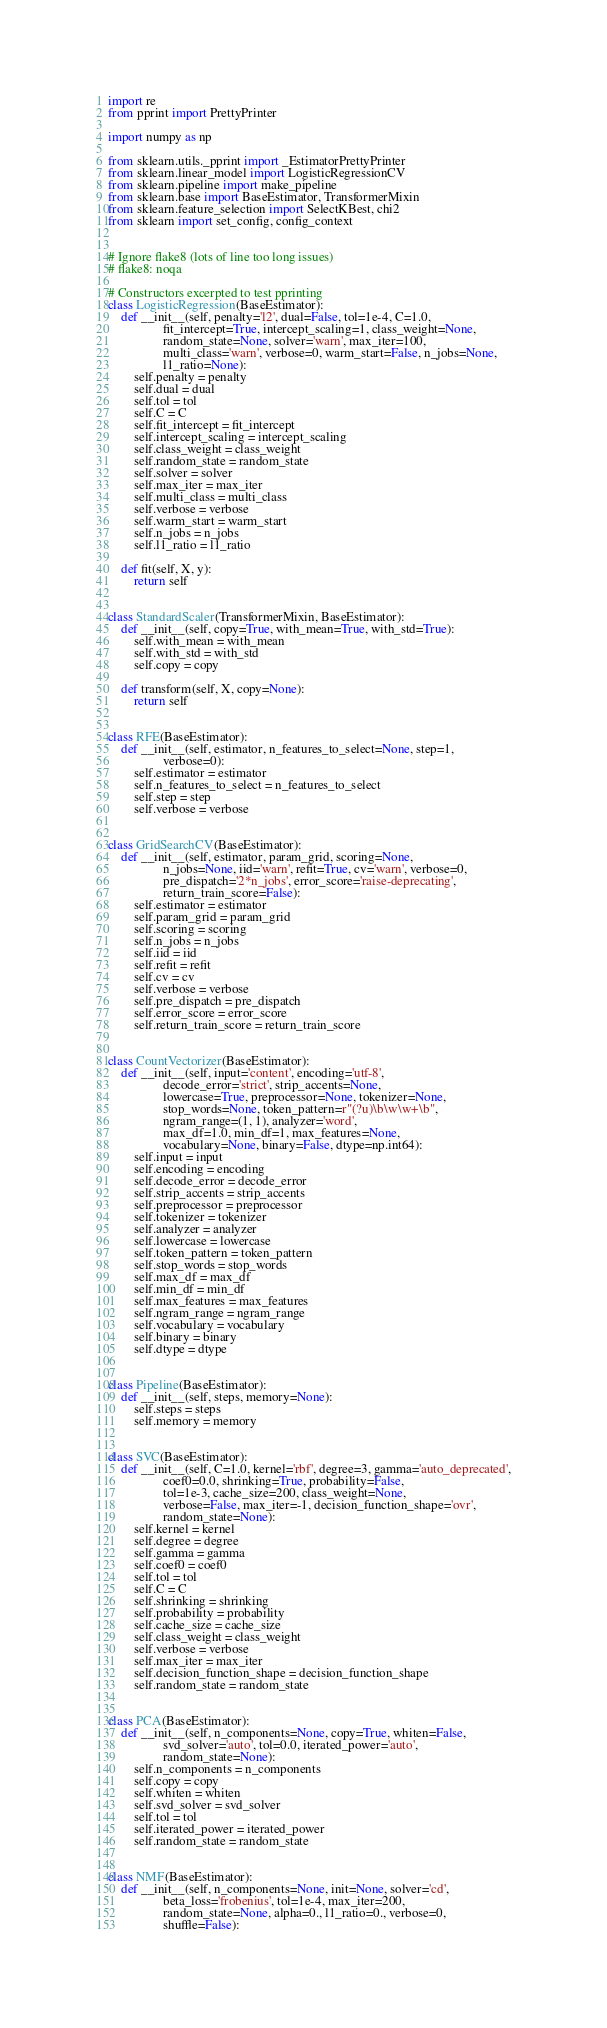Convert code to text. <code><loc_0><loc_0><loc_500><loc_500><_Python_>import re
from pprint import PrettyPrinter

import numpy as np

from sklearn.utils._pprint import _EstimatorPrettyPrinter
from sklearn.linear_model import LogisticRegressionCV
from sklearn.pipeline import make_pipeline
from sklearn.base import BaseEstimator, TransformerMixin
from sklearn.feature_selection import SelectKBest, chi2
from sklearn import set_config, config_context


# Ignore flake8 (lots of line too long issues)
# flake8: noqa

# Constructors excerpted to test pprinting
class LogisticRegression(BaseEstimator):
    def __init__(self, penalty='l2', dual=False, tol=1e-4, C=1.0,
                 fit_intercept=True, intercept_scaling=1, class_weight=None,
                 random_state=None, solver='warn', max_iter=100,
                 multi_class='warn', verbose=0, warm_start=False, n_jobs=None,
                 l1_ratio=None):
        self.penalty = penalty
        self.dual = dual
        self.tol = tol
        self.C = C
        self.fit_intercept = fit_intercept
        self.intercept_scaling = intercept_scaling
        self.class_weight = class_weight
        self.random_state = random_state
        self.solver = solver
        self.max_iter = max_iter
        self.multi_class = multi_class
        self.verbose = verbose
        self.warm_start = warm_start
        self.n_jobs = n_jobs
        self.l1_ratio = l1_ratio

    def fit(self, X, y):
        return self


class StandardScaler(TransformerMixin, BaseEstimator):
    def __init__(self, copy=True, with_mean=True, with_std=True):
        self.with_mean = with_mean
        self.with_std = with_std
        self.copy = copy

    def transform(self, X, copy=None):
        return self


class RFE(BaseEstimator):
    def __init__(self, estimator, n_features_to_select=None, step=1,
                 verbose=0):
        self.estimator = estimator
        self.n_features_to_select = n_features_to_select
        self.step = step
        self.verbose = verbose


class GridSearchCV(BaseEstimator):
    def __init__(self, estimator, param_grid, scoring=None,
                 n_jobs=None, iid='warn', refit=True, cv='warn', verbose=0,
                 pre_dispatch='2*n_jobs', error_score='raise-deprecating',
                 return_train_score=False):
        self.estimator = estimator
        self.param_grid = param_grid
        self.scoring = scoring
        self.n_jobs = n_jobs
        self.iid = iid
        self.refit = refit
        self.cv = cv
        self.verbose = verbose
        self.pre_dispatch = pre_dispatch
        self.error_score = error_score
        self.return_train_score = return_train_score


class CountVectorizer(BaseEstimator):
    def __init__(self, input='content', encoding='utf-8',
                 decode_error='strict', strip_accents=None,
                 lowercase=True, preprocessor=None, tokenizer=None,
                 stop_words=None, token_pattern=r"(?u)\b\w\w+\b",
                 ngram_range=(1, 1), analyzer='word',
                 max_df=1.0, min_df=1, max_features=None,
                 vocabulary=None, binary=False, dtype=np.int64):
        self.input = input
        self.encoding = encoding
        self.decode_error = decode_error
        self.strip_accents = strip_accents
        self.preprocessor = preprocessor
        self.tokenizer = tokenizer
        self.analyzer = analyzer
        self.lowercase = lowercase
        self.token_pattern = token_pattern
        self.stop_words = stop_words
        self.max_df = max_df
        self.min_df = min_df
        self.max_features = max_features
        self.ngram_range = ngram_range
        self.vocabulary = vocabulary
        self.binary = binary
        self.dtype = dtype


class Pipeline(BaseEstimator):
    def __init__(self, steps, memory=None):
        self.steps = steps
        self.memory = memory


class SVC(BaseEstimator):
    def __init__(self, C=1.0, kernel='rbf', degree=3, gamma='auto_deprecated',
                 coef0=0.0, shrinking=True, probability=False,
                 tol=1e-3, cache_size=200, class_weight=None,
                 verbose=False, max_iter=-1, decision_function_shape='ovr',
                 random_state=None):
        self.kernel = kernel
        self.degree = degree
        self.gamma = gamma
        self.coef0 = coef0
        self.tol = tol
        self.C = C
        self.shrinking = shrinking
        self.probability = probability
        self.cache_size = cache_size
        self.class_weight = class_weight
        self.verbose = verbose
        self.max_iter = max_iter
        self.decision_function_shape = decision_function_shape
        self.random_state = random_state


class PCA(BaseEstimator):
    def __init__(self, n_components=None, copy=True, whiten=False,
                 svd_solver='auto', tol=0.0, iterated_power='auto',
                 random_state=None):
        self.n_components = n_components
        self.copy = copy
        self.whiten = whiten
        self.svd_solver = svd_solver
        self.tol = tol
        self.iterated_power = iterated_power
        self.random_state = random_state


class NMF(BaseEstimator):
    def __init__(self, n_components=None, init=None, solver='cd',
                 beta_loss='frobenius', tol=1e-4, max_iter=200,
                 random_state=None, alpha=0., l1_ratio=0., verbose=0,
                 shuffle=False):</code> 